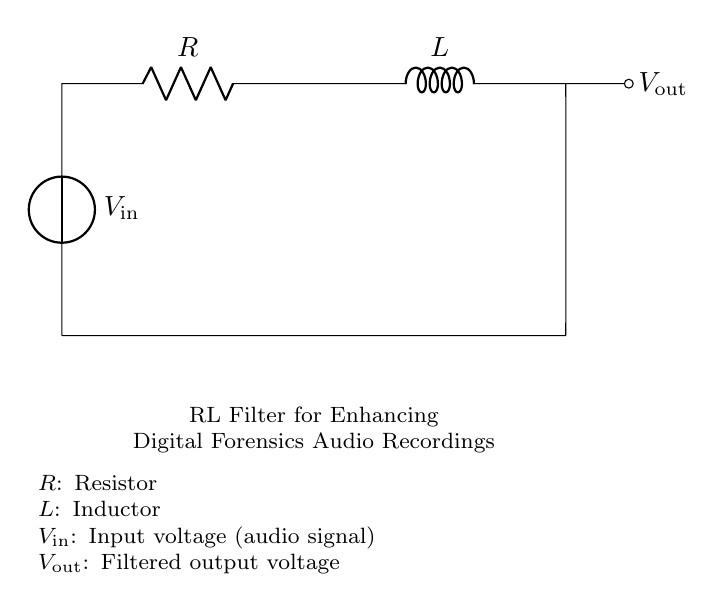What is the input voltage of the circuit? The input voltage is labeled as \(V_\text{in}\), which is the voltage provided to the circuit. The diagram does not specify a number, but it is indicated as a variable input.
Answer: \(V_\text{in}\) What components are present in the circuit? The circuit diagram shows two components: a resistor and an inductor. These are labeled as \(R\) and \(L\) respectively, indicating their roles in the circuit.
Answer: Resistor and inductor What is the output voltage of the circuit? The output voltage is labeled as \(V_\text{out}\), which represents the voltage after the RL filter process. The diagram indicates that this voltage is taken from the junction of the inductor and the output connection.
Answer: \(V_\text{out}\) How does the inductor affect the signal in this filter? The inductor plays a critical role in filtering by opposing changes in current, which can smooth out high-frequency noise in the audio signal, allowing lower frequencies to pass more easily. This is due to its property of impedance increasing with frequency.
Answer: Smooths high frequencies What is the purpose of the resistor in the RL filter? The resistor limits the current flowing through the circuit and affects the time constant, which is crucial for filtering signals. It helps to set the cutoff frequency of the filter, determining which frequencies are reduced and which are allowed to pass.
Answer: Limits current and sets cutoff frequency What is the overall effect of the RL filter on an audio signal? The RL filter enhances the quality of audio recordings by reducing noise, particularly high-frequency components that can obscure relevant sound information. This results in clearer and more intelligible audio signals for analysis in digital forensics.
Answer: Reduces noise and enhances clarity 